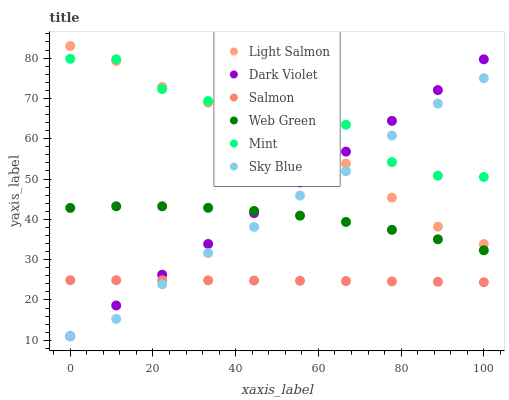Does Salmon have the minimum area under the curve?
Answer yes or no. Yes. Does Mint have the maximum area under the curve?
Answer yes or no. Yes. Does Web Green have the minimum area under the curve?
Answer yes or no. No. Does Web Green have the maximum area under the curve?
Answer yes or no. No. Is Dark Violet the smoothest?
Answer yes or no. Yes. Is Mint the roughest?
Answer yes or no. Yes. Is Salmon the smoothest?
Answer yes or no. No. Is Salmon the roughest?
Answer yes or no. No. Does Dark Violet have the lowest value?
Answer yes or no. Yes. Does Salmon have the lowest value?
Answer yes or no. No. Does Light Salmon have the highest value?
Answer yes or no. Yes. Does Web Green have the highest value?
Answer yes or no. No. Is Web Green less than Mint?
Answer yes or no. Yes. Is Light Salmon greater than Salmon?
Answer yes or no. Yes. Does Sky Blue intersect Light Salmon?
Answer yes or no. Yes. Is Sky Blue less than Light Salmon?
Answer yes or no. No. Is Sky Blue greater than Light Salmon?
Answer yes or no. No. Does Web Green intersect Mint?
Answer yes or no. No. 